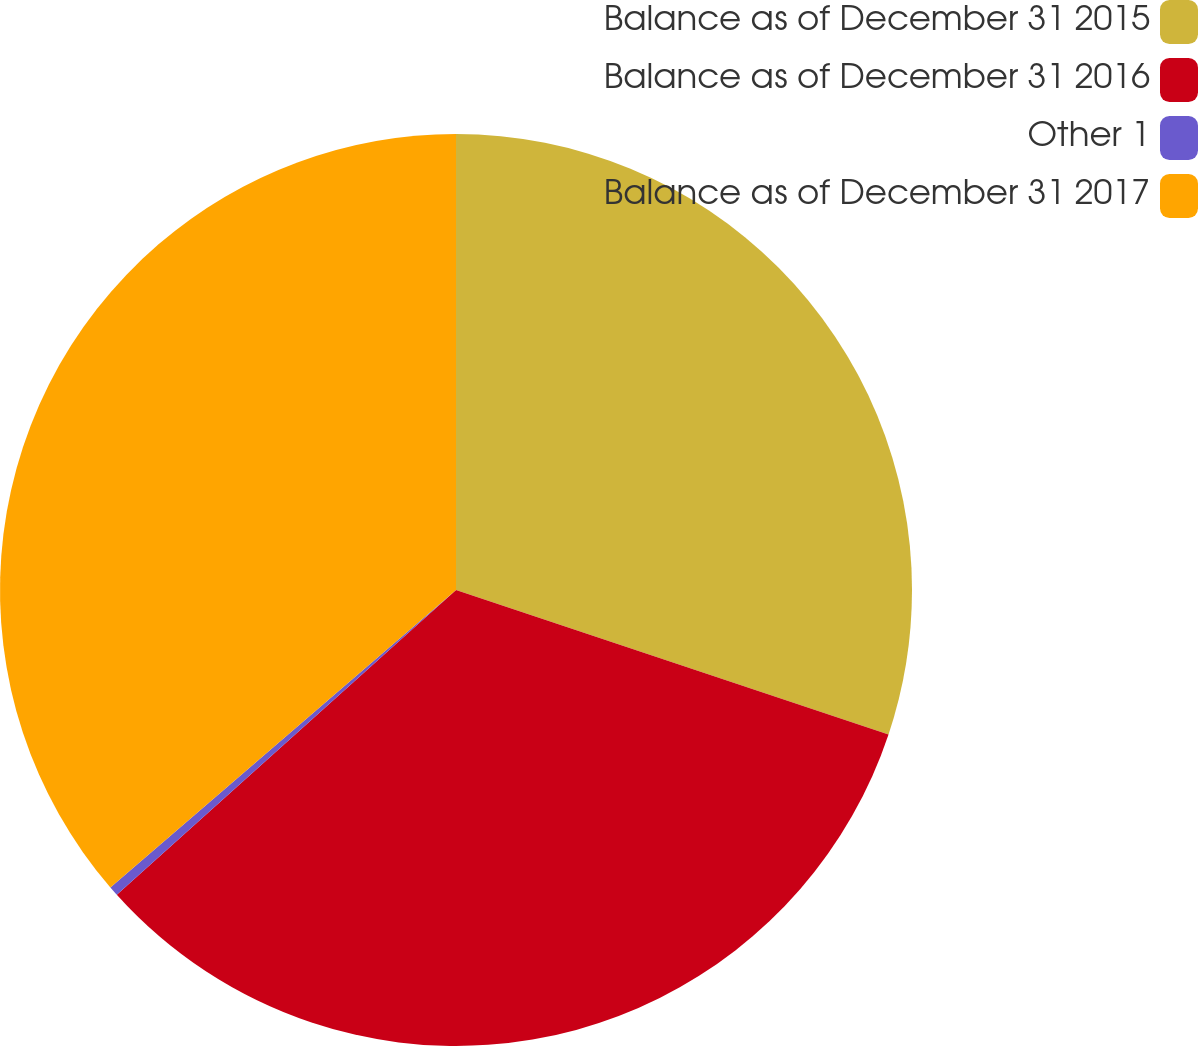Convert chart to OTSL. <chart><loc_0><loc_0><loc_500><loc_500><pie_chart><fcel>Balance as of December 31 2015<fcel>Balance as of December 31 2016<fcel>Other 1<fcel>Balance as of December 31 2017<nl><fcel>30.13%<fcel>33.22%<fcel>0.34%<fcel>36.31%<nl></chart> 